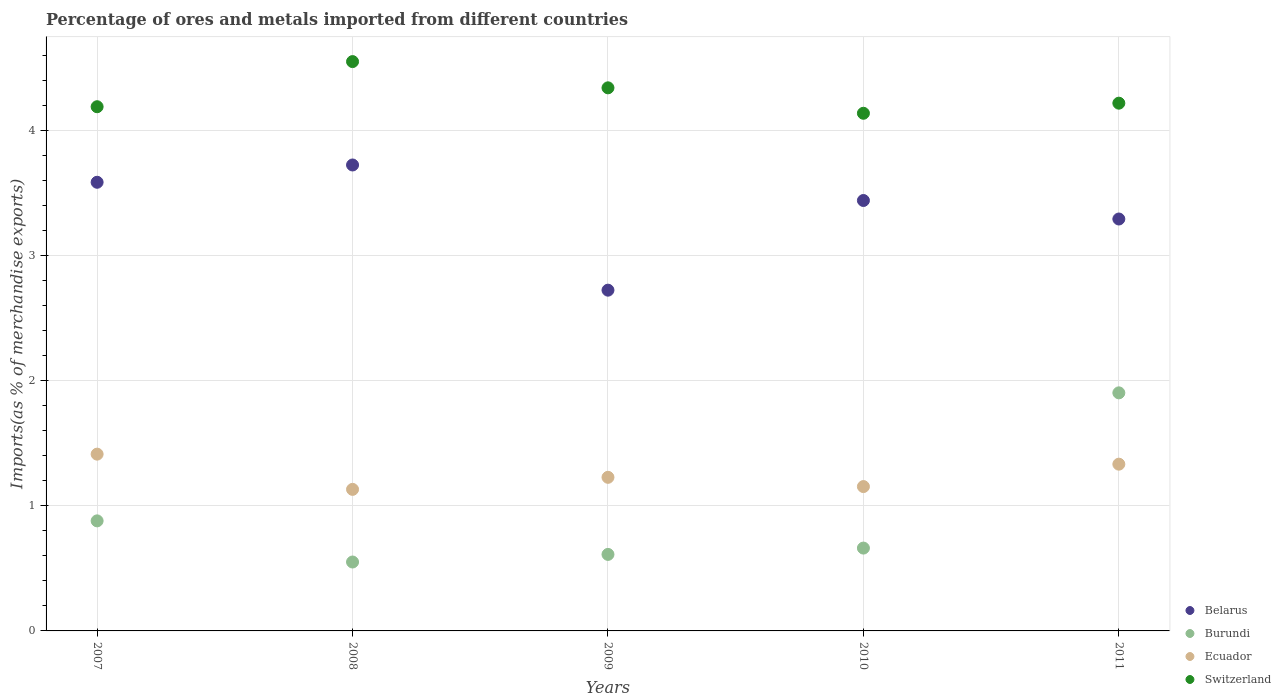How many different coloured dotlines are there?
Your answer should be very brief. 4. What is the percentage of imports to different countries in Belarus in 2007?
Offer a very short reply. 3.59. Across all years, what is the maximum percentage of imports to different countries in Ecuador?
Keep it short and to the point. 1.41. Across all years, what is the minimum percentage of imports to different countries in Belarus?
Your answer should be very brief. 2.72. What is the total percentage of imports to different countries in Burundi in the graph?
Offer a very short reply. 4.61. What is the difference between the percentage of imports to different countries in Burundi in 2008 and that in 2010?
Offer a very short reply. -0.11. What is the difference between the percentage of imports to different countries in Ecuador in 2007 and the percentage of imports to different countries in Burundi in 2008?
Offer a terse response. 0.86. What is the average percentage of imports to different countries in Switzerland per year?
Your answer should be compact. 4.29. In the year 2009, what is the difference between the percentage of imports to different countries in Burundi and percentage of imports to different countries in Ecuador?
Your answer should be very brief. -0.62. In how many years, is the percentage of imports to different countries in Burundi greater than 0.6000000000000001 %?
Your answer should be very brief. 4. What is the ratio of the percentage of imports to different countries in Burundi in 2008 to that in 2011?
Ensure brevity in your answer.  0.29. Is the difference between the percentage of imports to different countries in Burundi in 2007 and 2010 greater than the difference between the percentage of imports to different countries in Ecuador in 2007 and 2010?
Keep it short and to the point. No. What is the difference between the highest and the second highest percentage of imports to different countries in Burundi?
Your answer should be very brief. 1.02. What is the difference between the highest and the lowest percentage of imports to different countries in Switzerland?
Your answer should be very brief. 0.41. Is it the case that in every year, the sum of the percentage of imports to different countries in Switzerland and percentage of imports to different countries in Burundi  is greater than the sum of percentage of imports to different countries in Ecuador and percentage of imports to different countries in Belarus?
Your answer should be compact. Yes. Is it the case that in every year, the sum of the percentage of imports to different countries in Ecuador and percentage of imports to different countries in Switzerland  is greater than the percentage of imports to different countries in Belarus?
Provide a succinct answer. Yes. Is the percentage of imports to different countries in Burundi strictly greater than the percentage of imports to different countries in Belarus over the years?
Offer a very short reply. No. Is the percentage of imports to different countries in Burundi strictly less than the percentage of imports to different countries in Switzerland over the years?
Provide a succinct answer. Yes. How many dotlines are there?
Your answer should be very brief. 4. Are the values on the major ticks of Y-axis written in scientific E-notation?
Give a very brief answer. No. How many legend labels are there?
Keep it short and to the point. 4. What is the title of the graph?
Ensure brevity in your answer.  Percentage of ores and metals imported from different countries. Does "High income: OECD" appear as one of the legend labels in the graph?
Keep it short and to the point. No. What is the label or title of the Y-axis?
Provide a succinct answer. Imports(as % of merchandise exports). What is the Imports(as % of merchandise exports) in Belarus in 2007?
Your answer should be very brief. 3.59. What is the Imports(as % of merchandise exports) of Burundi in 2007?
Offer a very short reply. 0.88. What is the Imports(as % of merchandise exports) of Ecuador in 2007?
Provide a short and direct response. 1.41. What is the Imports(as % of merchandise exports) of Switzerland in 2007?
Give a very brief answer. 4.19. What is the Imports(as % of merchandise exports) of Belarus in 2008?
Keep it short and to the point. 3.73. What is the Imports(as % of merchandise exports) in Burundi in 2008?
Give a very brief answer. 0.55. What is the Imports(as % of merchandise exports) of Ecuador in 2008?
Your answer should be compact. 1.13. What is the Imports(as % of merchandise exports) in Switzerland in 2008?
Offer a very short reply. 4.55. What is the Imports(as % of merchandise exports) of Belarus in 2009?
Your answer should be compact. 2.72. What is the Imports(as % of merchandise exports) in Burundi in 2009?
Give a very brief answer. 0.61. What is the Imports(as % of merchandise exports) of Ecuador in 2009?
Your response must be concise. 1.23. What is the Imports(as % of merchandise exports) of Switzerland in 2009?
Keep it short and to the point. 4.34. What is the Imports(as % of merchandise exports) in Belarus in 2010?
Ensure brevity in your answer.  3.44. What is the Imports(as % of merchandise exports) of Burundi in 2010?
Keep it short and to the point. 0.66. What is the Imports(as % of merchandise exports) of Ecuador in 2010?
Keep it short and to the point. 1.15. What is the Imports(as % of merchandise exports) of Switzerland in 2010?
Ensure brevity in your answer.  4.14. What is the Imports(as % of merchandise exports) of Belarus in 2011?
Your answer should be compact. 3.29. What is the Imports(as % of merchandise exports) of Burundi in 2011?
Your response must be concise. 1.9. What is the Imports(as % of merchandise exports) of Ecuador in 2011?
Your answer should be very brief. 1.33. What is the Imports(as % of merchandise exports) of Switzerland in 2011?
Your answer should be compact. 4.22. Across all years, what is the maximum Imports(as % of merchandise exports) in Belarus?
Your answer should be compact. 3.73. Across all years, what is the maximum Imports(as % of merchandise exports) in Burundi?
Provide a succinct answer. 1.9. Across all years, what is the maximum Imports(as % of merchandise exports) in Ecuador?
Your response must be concise. 1.41. Across all years, what is the maximum Imports(as % of merchandise exports) in Switzerland?
Offer a very short reply. 4.55. Across all years, what is the minimum Imports(as % of merchandise exports) of Belarus?
Your response must be concise. 2.72. Across all years, what is the minimum Imports(as % of merchandise exports) of Burundi?
Give a very brief answer. 0.55. Across all years, what is the minimum Imports(as % of merchandise exports) of Ecuador?
Provide a succinct answer. 1.13. Across all years, what is the minimum Imports(as % of merchandise exports) of Switzerland?
Keep it short and to the point. 4.14. What is the total Imports(as % of merchandise exports) of Belarus in the graph?
Make the answer very short. 16.77. What is the total Imports(as % of merchandise exports) of Burundi in the graph?
Your answer should be very brief. 4.61. What is the total Imports(as % of merchandise exports) in Ecuador in the graph?
Keep it short and to the point. 6.26. What is the total Imports(as % of merchandise exports) in Switzerland in the graph?
Keep it short and to the point. 21.44. What is the difference between the Imports(as % of merchandise exports) in Belarus in 2007 and that in 2008?
Keep it short and to the point. -0.14. What is the difference between the Imports(as % of merchandise exports) in Burundi in 2007 and that in 2008?
Your answer should be compact. 0.33. What is the difference between the Imports(as % of merchandise exports) in Ecuador in 2007 and that in 2008?
Keep it short and to the point. 0.28. What is the difference between the Imports(as % of merchandise exports) in Switzerland in 2007 and that in 2008?
Provide a short and direct response. -0.36. What is the difference between the Imports(as % of merchandise exports) of Belarus in 2007 and that in 2009?
Make the answer very short. 0.86. What is the difference between the Imports(as % of merchandise exports) of Burundi in 2007 and that in 2009?
Your response must be concise. 0.27. What is the difference between the Imports(as % of merchandise exports) of Ecuador in 2007 and that in 2009?
Provide a short and direct response. 0.19. What is the difference between the Imports(as % of merchandise exports) in Switzerland in 2007 and that in 2009?
Give a very brief answer. -0.15. What is the difference between the Imports(as % of merchandise exports) of Belarus in 2007 and that in 2010?
Provide a short and direct response. 0.15. What is the difference between the Imports(as % of merchandise exports) in Burundi in 2007 and that in 2010?
Your answer should be compact. 0.22. What is the difference between the Imports(as % of merchandise exports) in Ecuador in 2007 and that in 2010?
Give a very brief answer. 0.26. What is the difference between the Imports(as % of merchandise exports) in Switzerland in 2007 and that in 2010?
Provide a succinct answer. 0.05. What is the difference between the Imports(as % of merchandise exports) of Belarus in 2007 and that in 2011?
Give a very brief answer. 0.29. What is the difference between the Imports(as % of merchandise exports) of Burundi in 2007 and that in 2011?
Your answer should be compact. -1.02. What is the difference between the Imports(as % of merchandise exports) in Ecuador in 2007 and that in 2011?
Keep it short and to the point. 0.08. What is the difference between the Imports(as % of merchandise exports) of Switzerland in 2007 and that in 2011?
Offer a very short reply. -0.03. What is the difference between the Imports(as % of merchandise exports) in Burundi in 2008 and that in 2009?
Your answer should be compact. -0.06. What is the difference between the Imports(as % of merchandise exports) of Ecuador in 2008 and that in 2009?
Make the answer very short. -0.1. What is the difference between the Imports(as % of merchandise exports) in Switzerland in 2008 and that in 2009?
Make the answer very short. 0.21. What is the difference between the Imports(as % of merchandise exports) in Belarus in 2008 and that in 2010?
Offer a very short reply. 0.28. What is the difference between the Imports(as % of merchandise exports) in Burundi in 2008 and that in 2010?
Offer a very short reply. -0.11. What is the difference between the Imports(as % of merchandise exports) of Ecuador in 2008 and that in 2010?
Your response must be concise. -0.02. What is the difference between the Imports(as % of merchandise exports) in Switzerland in 2008 and that in 2010?
Provide a succinct answer. 0.41. What is the difference between the Imports(as % of merchandise exports) in Belarus in 2008 and that in 2011?
Make the answer very short. 0.43. What is the difference between the Imports(as % of merchandise exports) in Burundi in 2008 and that in 2011?
Ensure brevity in your answer.  -1.35. What is the difference between the Imports(as % of merchandise exports) of Ecuador in 2008 and that in 2011?
Your response must be concise. -0.2. What is the difference between the Imports(as % of merchandise exports) in Switzerland in 2008 and that in 2011?
Ensure brevity in your answer.  0.33. What is the difference between the Imports(as % of merchandise exports) of Belarus in 2009 and that in 2010?
Provide a short and direct response. -0.72. What is the difference between the Imports(as % of merchandise exports) of Burundi in 2009 and that in 2010?
Offer a terse response. -0.05. What is the difference between the Imports(as % of merchandise exports) of Ecuador in 2009 and that in 2010?
Ensure brevity in your answer.  0.07. What is the difference between the Imports(as % of merchandise exports) in Switzerland in 2009 and that in 2010?
Give a very brief answer. 0.2. What is the difference between the Imports(as % of merchandise exports) in Belarus in 2009 and that in 2011?
Keep it short and to the point. -0.57. What is the difference between the Imports(as % of merchandise exports) of Burundi in 2009 and that in 2011?
Offer a terse response. -1.29. What is the difference between the Imports(as % of merchandise exports) of Ecuador in 2009 and that in 2011?
Your response must be concise. -0.11. What is the difference between the Imports(as % of merchandise exports) of Switzerland in 2009 and that in 2011?
Keep it short and to the point. 0.12. What is the difference between the Imports(as % of merchandise exports) in Belarus in 2010 and that in 2011?
Keep it short and to the point. 0.15. What is the difference between the Imports(as % of merchandise exports) of Burundi in 2010 and that in 2011?
Keep it short and to the point. -1.24. What is the difference between the Imports(as % of merchandise exports) in Ecuador in 2010 and that in 2011?
Provide a short and direct response. -0.18. What is the difference between the Imports(as % of merchandise exports) in Switzerland in 2010 and that in 2011?
Your answer should be compact. -0.08. What is the difference between the Imports(as % of merchandise exports) in Belarus in 2007 and the Imports(as % of merchandise exports) in Burundi in 2008?
Ensure brevity in your answer.  3.04. What is the difference between the Imports(as % of merchandise exports) of Belarus in 2007 and the Imports(as % of merchandise exports) of Ecuador in 2008?
Provide a short and direct response. 2.46. What is the difference between the Imports(as % of merchandise exports) of Belarus in 2007 and the Imports(as % of merchandise exports) of Switzerland in 2008?
Keep it short and to the point. -0.96. What is the difference between the Imports(as % of merchandise exports) in Burundi in 2007 and the Imports(as % of merchandise exports) in Ecuador in 2008?
Provide a succinct answer. -0.25. What is the difference between the Imports(as % of merchandise exports) in Burundi in 2007 and the Imports(as % of merchandise exports) in Switzerland in 2008?
Your response must be concise. -3.67. What is the difference between the Imports(as % of merchandise exports) in Ecuador in 2007 and the Imports(as % of merchandise exports) in Switzerland in 2008?
Provide a succinct answer. -3.14. What is the difference between the Imports(as % of merchandise exports) in Belarus in 2007 and the Imports(as % of merchandise exports) in Burundi in 2009?
Your answer should be compact. 2.98. What is the difference between the Imports(as % of merchandise exports) of Belarus in 2007 and the Imports(as % of merchandise exports) of Ecuador in 2009?
Offer a terse response. 2.36. What is the difference between the Imports(as % of merchandise exports) in Belarus in 2007 and the Imports(as % of merchandise exports) in Switzerland in 2009?
Provide a short and direct response. -0.76. What is the difference between the Imports(as % of merchandise exports) in Burundi in 2007 and the Imports(as % of merchandise exports) in Ecuador in 2009?
Offer a very short reply. -0.35. What is the difference between the Imports(as % of merchandise exports) of Burundi in 2007 and the Imports(as % of merchandise exports) of Switzerland in 2009?
Offer a very short reply. -3.46. What is the difference between the Imports(as % of merchandise exports) of Ecuador in 2007 and the Imports(as % of merchandise exports) of Switzerland in 2009?
Your answer should be very brief. -2.93. What is the difference between the Imports(as % of merchandise exports) in Belarus in 2007 and the Imports(as % of merchandise exports) in Burundi in 2010?
Give a very brief answer. 2.92. What is the difference between the Imports(as % of merchandise exports) of Belarus in 2007 and the Imports(as % of merchandise exports) of Ecuador in 2010?
Provide a succinct answer. 2.43. What is the difference between the Imports(as % of merchandise exports) in Belarus in 2007 and the Imports(as % of merchandise exports) in Switzerland in 2010?
Your answer should be compact. -0.55. What is the difference between the Imports(as % of merchandise exports) in Burundi in 2007 and the Imports(as % of merchandise exports) in Ecuador in 2010?
Make the answer very short. -0.27. What is the difference between the Imports(as % of merchandise exports) in Burundi in 2007 and the Imports(as % of merchandise exports) in Switzerland in 2010?
Ensure brevity in your answer.  -3.26. What is the difference between the Imports(as % of merchandise exports) of Ecuador in 2007 and the Imports(as % of merchandise exports) of Switzerland in 2010?
Your answer should be compact. -2.73. What is the difference between the Imports(as % of merchandise exports) in Belarus in 2007 and the Imports(as % of merchandise exports) in Burundi in 2011?
Keep it short and to the point. 1.68. What is the difference between the Imports(as % of merchandise exports) in Belarus in 2007 and the Imports(as % of merchandise exports) in Ecuador in 2011?
Your answer should be compact. 2.25. What is the difference between the Imports(as % of merchandise exports) of Belarus in 2007 and the Imports(as % of merchandise exports) of Switzerland in 2011?
Make the answer very short. -0.63. What is the difference between the Imports(as % of merchandise exports) in Burundi in 2007 and the Imports(as % of merchandise exports) in Ecuador in 2011?
Keep it short and to the point. -0.45. What is the difference between the Imports(as % of merchandise exports) in Burundi in 2007 and the Imports(as % of merchandise exports) in Switzerland in 2011?
Your response must be concise. -3.34. What is the difference between the Imports(as % of merchandise exports) in Ecuador in 2007 and the Imports(as % of merchandise exports) in Switzerland in 2011?
Offer a very short reply. -2.81. What is the difference between the Imports(as % of merchandise exports) in Belarus in 2008 and the Imports(as % of merchandise exports) in Burundi in 2009?
Provide a succinct answer. 3.11. What is the difference between the Imports(as % of merchandise exports) in Belarus in 2008 and the Imports(as % of merchandise exports) in Ecuador in 2009?
Provide a succinct answer. 2.5. What is the difference between the Imports(as % of merchandise exports) in Belarus in 2008 and the Imports(as % of merchandise exports) in Switzerland in 2009?
Provide a succinct answer. -0.62. What is the difference between the Imports(as % of merchandise exports) of Burundi in 2008 and the Imports(as % of merchandise exports) of Ecuador in 2009?
Offer a terse response. -0.68. What is the difference between the Imports(as % of merchandise exports) in Burundi in 2008 and the Imports(as % of merchandise exports) in Switzerland in 2009?
Make the answer very short. -3.79. What is the difference between the Imports(as % of merchandise exports) of Ecuador in 2008 and the Imports(as % of merchandise exports) of Switzerland in 2009?
Provide a succinct answer. -3.21. What is the difference between the Imports(as % of merchandise exports) of Belarus in 2008 and the Imports(as % of merchandise exports) of Burundi in 2010?
Keep it short and to the point. 3.06. What is the difference between the Imports(as % of merchandise exports) in Belarus in 2008 and the Imports(as % of merchandise exports) in Ecuador in 2010?
Provide a short and direct response. 2.57. What is the difference between the Imports(as % of merchandise exports) of Belarus in 2008 and the Imports(as % of merchandise exports) of Switzerland in 2010?
Ensure brevity in your answer.  -0.41. What is the difference between the Imports(as % of merchandise exports) in Burundi in 2008 and the Imports(as % of merchandise exports) in Ecuador in 2010?
Ensure brevity in your answer.  -0.6. What is the difference between the Imports(as % of merchandise exports) in Burundi in 2008 and the Imports(as % of merchandise exports) in Switzerland in 2010?
Ensure brevity in your answer.  -3.59. What is the difference between the Imports(as % of merchandise exports) in Ecuador in 2008 and the Imports(as % of merchandise exports) in Switzerland in 2010?
Your answer should be compact. -3.01. What is the difference between the Imports(as % of merchandise exports) in Belarus in 2008 and the Imports(as % of merchandise exports) in Burundi in 2011?
Ensure brevity in your answer.  1.82. What is the difference between the Imports(as % of merchandise exports) of Belarus in 2008 and the Imports(as % of merchandise exports) of Ecuador in 2011?
Ensure brevity in your answer.  2.39. What is the difference between the Imports(as % of merchandise exports) of Belarus in 2008 and the Imports(as % of merchandise exports) of Switzerland in 2011?
Provide a succinct answer. -0.49. What is the difference between the Imports(as % of merchandise exports) of Burundi in 2008 and the Imports(as % of merchandise exports) of Ecuador in 2011?
Your response must be concise. -0.78. What is the difference between the Imports(as % of merchandise exports) in Burundi in 2008 and the Imports(as % of merchandise exports) in Switzerland in 2011?
Your answer should be compact. -3.67. What is the difference between the Imports(as % of merchandise exports) in Ecuador in 2008 and the Imports(as % of merchandise exports) in Switzerland in 2011?
Keep it short and to the point. -3.09. What is the difference between the Imports(as % of merchandise exports) in Belarus in 2009 and the Imports(as % of merchandise exports) in Burundi in 2010?
Your answer should be compact. 2.06. What is the difference between the Imports(as % of merchandise exports) in Belarus in 2009 and the Imports(as % of merchandise exports) in Ecuador in 2010?
Provide a succinct answer. 1.57. What is the difference between the Imports(as % of merchandise exports) of Belarus in 2009 and the Imports(as % of merchandise exports) of Switzerland in 2010?
Your response must be concise. -1.41. What is the difference between the Imports(as % of merchandise exports) of Burundi in 2009 and the Imports(as % of merchandise exports) of Ecuador in 2010?
Keep it short and to the point. -0.54. What is the difference between the Imports(as % of merchandise exports) of Burundi in 2009 and the Imports(as % of merchandise exports) of Switzerland in 2010?
Give a very brief answer. -3.53. What is the difference between the Imports(as % of merchandise exports) of Ecuador in 2009 and the Imports(as % of merchandise exports) of Switzerland in 2010?
Your answer should be compact. -2.91. What is the difference between the Imports(as % of merchandise exports) in Belarus in 2009 and the Imports(as % of merchandise exports) in Burundi in 2011?
Your response must be concise. 0.82. What is the difference between the Imports(as % of merchandise exports) in Belarus in 2009 and the Imports(as % of merchandise exports) in Ecuador in 2011?
Provide a succinct answer. 1.39. What is the difference between the Imports(as % of merchandise exports) in Belarus in 2009 and the Imports(as % of merchandise exports) in Switzerland in 2011?
Ensure brevity in your answer.  -1.5. What is the difference between the Imports(as % of merchandise exports) of Burundi in 2009 and the Imports(as % of merchandise exports) of Ecuador in 2011?
Provide a short and direct response. -0.72. What is the difference between the Imports(as % of merchandise exports) in Burundi in 2009 and the Imports(as % of merchandise exports) in Switzerland in 2011?
Provide a succinct answer. -3.61. What is the difference between the Imports(as % of merchandise exports) in Ecuador in 2009 and the Imports(as % of merchandise exports) in Switzerland in 2011?
Make the answer very short. -2.99. What is the difference between the Imports(as % of merchandise exports) in Belarus in 2010 and the Imports(as % of merchandise exports) in Burundi in 2011?
Provide a succinct answer. 1.54. What is the difference between the Imports(as % of merchandise exports) of Belarus in 2010 and the Imports(as % of merchandise exports) of Ecuador in 2011?
Keep it short and to the point. 2.11. What is the difference between the Imports(as % of merchandise exports) of Belarus in 2010 and the Imports(as % of merchandise exports) of Switzerland in 2011?
Provide a succinct answer. -0.78. What is the difference between the Imports(as % of merchandise exports) in Burundi in 2010 and the Imports(as % of merchandise exports) in Ecuador in 2011?
Make the answer very short. -0.67. What is the difference between the Imports(as % of merchandise exports) of Burundi in 2010 and the Imports(as % of merchandise exports) of Switzerland in 2011?
Keep it short and to the point. -3.56. What is the difference between the Imports(as % of merchandise exports) in Ecuador in 2010 and the Imports(as % of merchandise exports) in Switzerland in 2011?
Your answer should be very brief. -3.07. What is the average Imports(as % of merchandise exports) in Belarus per year?
Provide a succinct answer. 3.35. What is the average Imports(as % of merchandise exports) of Burundi per year?
Provide a succinct answer. 0.92. What is the average Imports(as % of merchandise exports) of Ecuador per year?
Your answer should be very brief. 1.25. What is the average Imports(as % of merchandise exports) of Switzerland per year?
Make the answer very short. 4.29. In the year 2007, what is the difference between the Imports(as % of merchandise exports) in Belarus and Imports(as % of merchandise exports) in Burundi?
Your response must be concise. 2.71. In the year 2007, what is the difference between the Imports(as % of merchandise exports) in Belarus and Imports(as % of merchandise exports) in Ecuador?
Make the answer very short. 2.17. In the year 2007, what is the difference between the Imports(as % of merchandise exports) of Belarus and Imports(as % of merchandise exports) of Switzerland?
Keep it short and to the point. -0.6. In the year 2007, what is the difference between the Imports(as % of merchandise exports) of Burundi and Imports(as % of merchandise exports) of Ecuador?
Your response must be concise. -0.53. In the year 2007, what is the difference between the Imports(as % of merchandise exports) in Burundi and Imports(as % of merchandise exports) in Switzerland?
Provide a succinct answer. -3.31. In the year 2007, what is the difference between the Imports(as % of merchandise exports) of Ecuador and Imports(as % of merchandise exports) of Switzerland?
Offer a very short reply. -2.78. In the year 2008, what is the difference between the Imports(as % of merchandise exports) in Belarus and Imports(as % of merchandise exports) in Burundi?
Keep it short and to the point. 3.17. In the year 2008, what is the difference between the Imports(as % of merchandise exports) of Belarus and Imports(as % of merchandise exports) of Ecuador?
Make the answer very short. 2.59. In the year 2008, what is the difference between the Imports(as % of merchandise exports) in Belarus and Imports(as % of merchandise exports) in Switzerland?
Keep it short and to the point. -0.83. In the year 2008, what is the difference between the Imports(as % of merchandise exports) in Burundi and Imports(as % of merchandise exports) in Ecuador?
Offer a very short reply. -0.58. In the year 2008, what is the difference between the Imports(as % of merchandise exports) of Burundi and Imports(as % of merchandise exports) of Switzerland?
Your answer should be compact. -4. In the year 2008, what is the difference between the Imports(as % of merchandise exports) of Ecuador and Imports(as % of merchandise exports) of Switzerland?
Your answer should be compact. -3.42. In the year 2009, what is the difference between the Imports(as % of merchandise exports) of Belarus and Imports(as % of merchandise exports) of Burundi?
Provide a succinct answer. 2.11. In the year 2009, what is the difference between the Imports(as % of merchandise exports) in Belarus and Imports(as % of merchandise exports) in Ecuador?
Offer a very short reply. 1.5. In the year 2009, what is the difference between the Imports(as % of merchandise exports) of Belarus and Imports(as % of merchandise exports) of Switzerland?
Provide a short and direct response. -1.62. In the year 2009, what is the difference between the Imports(as % of merchandise exports) of Burundi and Imports(as % of merchandise exports) of Ecuador?
Offer a very short reply. -0.62. In the year 2009, what is the difference between the Imports(as % of merchandise exports) in Burundi and Imports(as % of merchandise exports) in Switzerland?
Give a very brief answer. -3.73. In the year 2009, what is the difference between the Imports(as % of merchandise exports) in Ecuador and Imports(as % of merchandise exports) in Switzerland?
Your response must be concise. -3.11. In the year 2010, what is the difference between the Imports(as % of merchandise exports) of Belarus and Imports(as % of merchandise exports) of Burundi?
Make the answer very short. 2.78. In the year 2010, what is the difference between the Imports(as % of merchandise exports) in Belarus and Imports(as % of merchandise exports) in Ecuador?
Keep it short and to the point. 2.29. In the year 2010, what is the difference between the Imports(as % of merchandise exports) in Belarus and Imports(as % of merchandise exports) in Switzerland?
Provide a short and direct response. -0.7. In the year 2010, what is the difference between the Imports(as % of merchandise exports) in Burundi and Imports(as % of merchandise exports) in Ecuador?
Offer a terse response. -0.49. In the year 2010, what is the difference between the Imports(as % of merchandise exports) in Burundi and Imports(as % of merchandise exports) in Switzerland?
Ensure brevity in your answer.  -3.48. In the year 2010, what is the difference between the Imports(as % of merchandise exports) of Ecuador and Imports(as % of merchandise exports) of Switzerland?
Offer a very short reply. -2.98. In the year 2011, what is the difference between the Imports(as % of merchandise exports) in Belarus and Imports(as % of merchandise exports) in Burundi?
Give a very brief answer. 1.39. In the year 2011, what is the difference between the Imports(as % of merchandise exports) of Belarus and Imports(as % of merchandise exports) of Ecuador?
Offer a terse response. 1.96. In the year 2011, what is the difference between the Imports(as % of merchandise exports) in Belarus and Imports(as % of merchandise exports) in Switzerland?
Provide a succinct answer. -0.93. In the year 2011, what is the difference between the Imports(as % of merchandise exports) of Burundi and Imports(as % of merchandise exports) of Ecuador?
Give a very brief answer. 0.57. In the year 2011, what is the difference between the Imports(as % of merchandise exports) of Burundi and Imports(as % of merchandise exports) of Switzerland?
Give a very brief answer. -2.32. In the year 2011, what is the difference between the Imports(as % of merchandise exports) in Ecuador and Imports(as % of merchandise exports) in Switzerland?
Give a very brief answer. -2.89. What is the ratio of the Imports(as % of merchandise exports) of Belarus in 2007 to that in 2008?
Provide a succinct answer. 0.96. What is the ratio of the Imports(as % of merchandise exports) of Burundi in 2007 to that in 2008?
Give a very brief answer. 1.6. What is the ratio of the Imports(as % of merchandise exports) of Ecuador in 2007 to that in 2008?
Your answer should be compact. 1.25. What is the ratio of the Imports(as % of merchandise exports) of Switzerland in 2007 to that in 2008?
Provide a succinct answer. 0.92. What is the ratio of the Imports(as % of merchandise exports) of Belarus in 2007 to that in 2009?
Offer a very short reply. 1.32. What is the ratio of the Imports(as % of merchandise exports) in Burundi in 2007 to that in 2009?
Your answer should be compact. 1.44. What is the ratio of the Imports(as % of merchandise exports) of Ecuador in 2007 to that in 2009?
Offer a terse response. 1.15. What is the ratio of the Imports(as % of merchandise exports) in Switzerland in 2007 to that in 2009?
Give a very brief answer. 0.97. What is the ratio of the Imports(as % of merchandise exports) of Belarus in 2007 to that in 2010?
Your response must be concise. 1.04. What is the ratio of the Imports(as % of merchandise exports) of Burundi in 2007 to that in 2010?
Make the answer very short. 1.33. What is the ratio of the Imports(as % of merchandise exports) of Ecuador in 2007 to that in 2010?
Your response must be concise. 1.22. What is the ratio of the Imports(as % of merchandise exports) of Switzerland in 2007 to that in 2010?
Your answer should be compact. 1.01. What is the ratio of the Imports(as % of merchandise exports) in Belarus in 2007 to that in 2011?
Offer a terse response. 1.09. What is the ratio of the Imports(as % of merchandise exports) of Burundi in 2007 to that in 2011?
Ensure brevity in your answer.  0.46. What is the ratio of the Imports(as % of merchandise exports) in Ecuador in 2007 to that in 2011?
Your answer should be very brief. 1.06. What is the ratio of the Imports(as % of merchandise exports) in Belarus in 2008 to that in 2009?
Your answer should be very brief. 1.37. What is the ratio of the Imports(as % of merchandise exports) in Burundi in 2008 to that in 2009?
Give a very brief answer. 0.9. What is the ratio of the Imports(as % of merchandise exports) of Ecuador in 2008 to that in 2009?
Provide a short and direct response. 0.92. What is the ratio of the Imports(as % of merchandise exports) in Switzerland in 2008 to that in 2009?
Offer a very short reply. 1.05. What is the ratio of the Imports(as % of merchandise exports) of Belarus in 2008 to that in 2010?
Offer a very short reply. 1.08. What is the ratio of the Imports(as % of merchandise exports) in Burundi in 2008 to that in 2010?
Your answer should be compact. 0.83. What is the ratio of the Imports(as % of merchandise exports) in Ecuador in 2008 to that in 2010?
Offer a terse response. 0.98. What is the ratio of the Imports(as % of merchandise exports) of Switzerland in 2008 to that in 2010?
Make the answer very short. 1.1. What is the ratio of the Imports(as % of merchandise exports) of Belarus in 2008 to that in 2011?
Your answer should be very brief. 1.13. What is the ratio of the Imports(as % of merchandise exports) in Burundi in 2008 to that in 2011?
Give a very brief answer. 0.29. What is the ratio of the Imports(as % of merchandise exports) in Ecuador in 2008 to that in 2011?
Give a very brief answer. 0.85. What is the ratio of the Imports(as % of merchandise exports) in Switzerland in 2008 to that in 2011?
Make the answer very short. 1.08. What is the ratio of the Imports(as % of merchandise exports) in Belarus in 2009 to that in 2010?
Provide a succinct answer. 0.79. What is the ratio of the Imports(as % of merchandise exports) in Burundi in 2009 to that in 2010?
Give a very brief answer. 0.92. What is the ratio of the Imports(as % of merchandise exports) of Ecuador in 2009 to that in 2010?
Give a very brief answer. 1.06. What is the ratio of the Imports(as % of merchandise exports) of Switzerland in 2009 to that in 2010?
Your answer should be compact. 1.05. What is the ratio of the Imports(as % of merchandise exports) in Belarus in 2009 to that in 2011?
Keep it short and to the point. 0.83. What is the ratio of the Imports(as % of merchandise exports) of Burundi in 2009 to that in 2011?
Your answer should be very brief. 0.32. What is the ratio of the Imports(as % of merchandise exports) in Ecuador in 2009 to that in 2011?
Offer a terse response. 0.92. What is the ratio of the Imports(as % of merchandise exports) of Switzerland in 2009 to that in 2011?
Give a very brief answer. 1.03. What is the ratio of the Imports(as % of merchandise exports) in Belarus in 2010 to that in 2011?
Provide a short and direct response. 1.04. What is the ratio of the Imports(as % of merchandise exports) in Burundi in 2010 to that in 2011?
Ensure brevity in your answer.  0.35. What is the ratio of the Imports(as % of merchandise exports) in Ecuador in 2010 to that in 2011?
Keep it short and to the point. 0.87. What is the ratio of the Imports(as % of merchandise exports) in Switzerland in 2010 to that in 2011?
Your response must be concise. 0.98. What is the difference between the highest and the second highest Imports(as % of merchandise exports) of Belarus?
Your answer should be very brief. 0.14. What is the difference between the highest and the second highest Imports(as % of merchandise exports) of Burundi?
Make the answer very short. 1.02. What is the difference between the highest and the second highest Imports(as % of merchandise exports) of Ecuador?
Keep it short and to the point. 0.08. What is the difference between the highest and the second highest Imports(as % of merchandise exports) of Switzerland?
Ensure brevity in your answer.  0.21. What is the difference between the highest and the lowest Imports(as % of merchandise exports) in Burundi?
Your response must be concise. 1.35. What is the difference between the highest and the lowest Imports(as % of merchandise exports) of Ecuador?
Provide a short and direct response. 0.28. What is the difference between the highest and the lowest Imports(as % of merchandise exports) of Switzerland?
Your answer should be very brief. 0.41. 